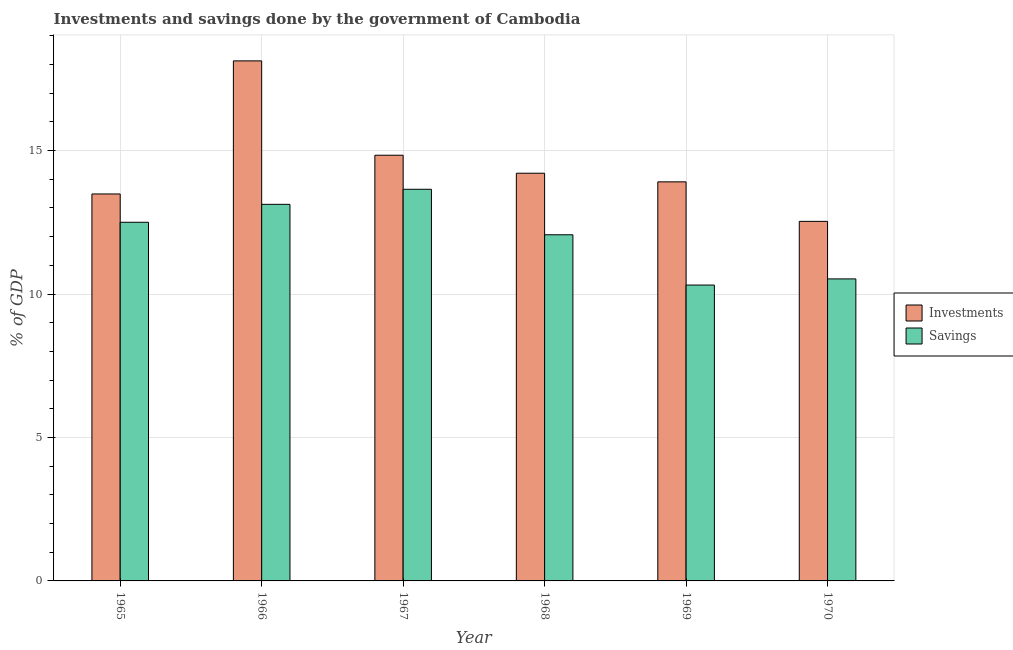How many different coloured bars are there?
Offer a terse response. 2. How many groups of bars are there?
Your response must be concise. 6. Are the number of bars per tick equal to the number of legend labels?
Keep it short and to the point. Yes. Are the number of bars on each tick of the X-axis equal?
Your response must be concise. Yes. How many bars are there on the 1st tick from the left?
Make the answer very short. 2. How many bars are there on the 2nd tick from the right?
Make the answer very short. 2. What is the label of the 6th group of bars from the left?
Make the answer very short. 1970. What is the investments of government in 1970?
Make the answer very short. 12.53. Across all years, what is the maximum savings of government?
Provide a short and direct response. 13.65. Across all years, what is the minimum savings of government?
Your answer should be very brief. 10.31. In which year was the investments of government maximum?
Ensure brevity in your answer.  1966. In which year was the investments of government minimum?
Your answer should be very brief. 1970. What is the total savings of government in the graph?
Your response must be concise. 72.18. What is the difference between the investments of government in 1967 and that in 1969?
Offer a terse response. 0.93. What is the difference between the investments of government in 1969 and the savings of government in 1970?
Provide a succinct answer. 1.38. What is the average savings of government per year?
Provide a succinct answer. 12.03. In how many years, is the investments of government greater than 7 %?
Give a very brief answer. 6. What is the ratio of the investments of government in 1965 to that in 1969?
Your answer should be compact. 0.97. Is the difference between the savings of government in 1965 and 1968 greater than the difference between the investments of government in 1965 and 1968?
Offer a very short reply. No. What is the difference between the highest and the second highest investments of government?
Provide a succinct answer. 3.29. What is the difference between the highest and the lowest investments of government?
Provide a short and direct response. 5.59. What does the 1st bar from the left in 1966 represents?
Your answer should be compact. Investments. What does the 2nd bar from the right in 1969 represents?
Give a very brief answer. Investments. How many bars are there?
Give a very brief answer. 12. Are all the bars in the graph horizontal?
Offer a very short reply. No. What is the difference between two consecutive major ticks on the Y-axis?
Offer a very short reply. 5. Are the values on the major ticks of Y-axis written in scientific E-notation?
Give a very brief answer. No. Where does the legend appear in the graph?
Provide a succinct answer. Center right. How many legend labels are there?
Provide a succinct answer. 2. How are the legend labels stacked?
Ensure brevity in your answer.  Vertical. What is the title of the graph?
Give a very brief answer. Investments and savings done by the government of Cambodia. Does "Birth rate" appear as one of the legend labels in the graph?
Offer a terse response. No. What is the label or title of the Y-axis?
Provide a short and direct response. % of GDP. What is the % of GDP of Investments in 1965?
Offer a very short reply. 13.49. What is the % of GDP of Savings in 1965?
Offer a terse response. 12.5. What is the % of GDP of Investments in 1966?
Your answer should be very brief. 18.12. What is the % of GDP in Savings in 1966?
Give a very brief answer. 13.12. What is the % of GDP in Investments in 1967?
Your response must be concise. 14.84. What is the % of GDP in Savings in 1967?
Give a very brief answer. 13.65. What is the % of GDP of Investments in 1968?
Provide a succinct answer. 14.21. What is the % of GDP in Savings in 1968?
Give a very brief answer. 12.06. What is the % of GDP of Investments in 1969?
Your answer should be compact. 13.91. What is the % of GDP in Savings in 1969?
Provide a succinct answer. 10.31. What is the % of GDP in Investments in 1970?
Make the answer very short. 12.53. What is the % of GDP in Savings in 1970?
Offer a terse response. 10.53. Across all years, what is the maximum % of GDP in Investments?
Provide a short and direct response. 18.12. Across all years, what is the maximum % of GDP in Savings?
Your answer should be very brief. 13.65. Across all years, what is the minimum % of GDP in Investments?
Offer a very short reply. 12.53. Across all years, what is the minimum % of GDP of Savings?
Your response must be concise. 10.31. What is the total % of GDP in Investments in the graph?
Your response must be concise. 87.1. What is the total % of GDP in Savings in the graph?
Offer a very short reply. 72.18. What is the difference between the % of GDP in Investments in 1965 and that in 1966?
Provide a short and direct response. -4.64. What is the difference between the % of GDP of Savings in 1965 and that in 1966?
Offer a terse response. -0.62. What is the difference between the % of GDP in Investments in 1965 and that in 1967?
Provide a short and direct response. -1.35. What is the difference between the % of GDP of Savings in 1965 and that in 1967?
Offer a terse response. -1.15. What is the difference between the % of GDP in Investments in 1965 and that in 1968?
Offer a very short reply. -0.72. What is the difference between the % of GDP of Savings in 1965 and that in 1968?
Keep it short and to the point. 0.44. What is the difference between the % of GDP in Investments in 1965 and that in 1969?
Ensure brevity in your answer.  -0.42. What is the difference between the % of GDP in Savings in 1965 and that in 1969?
Your response must be concise. 2.19. What is the difference between the % of GDP in Investments in 1965 and that in 1970?
Your answer should be compact. 0.96. What is the difference between the % of GDP of Savings in 1965 and that in 1970?
Offer a very short reply. 1.97. What is the difference between the % of GDP of Investments in 1966 and that in 1967?
Make the answer very short. 3.29. What is the difference between the % of GDP in Savings in 1966 and that in 1967?
Make the answer very short. -0.52. What is the difference between the % of GDP of Investments in 1966 and that in 1968?
Your answer should be very brief. 3.92. What is the difference between the % of GDP of Savings in 1966 and that in 1968?
Your answer should be very brief. 1.06. What is the difference between the % of GDP of Investments in 1966 and that in 1969?
Your answer should be compact. 4.22. What is the difference between the % of GDP of Savings in 1966 and that in 1969?
Your answer should be very brief. 2.81. What is the difference between the % of GDP in Investments in 1966 and that in 1970?
Your answer should be very brief. 5.59. What is the difference between the % of GDP in Savings in 1966 and that in 1970?
Provide a succinct answer. 2.6. What is the difference between the % of GDP in Investments in 1967 and that in 1968?
Offer a very short reply. 0.63. What is the difference between the % of GDP in Savings in 1967 and that in 1968?
Your answer should be very brief. 1.59. What is the difference between the % of GDP of Investments in 1967 and that in 1969?
Ensure brevity in your answer.  0.93. What is the difference between the % of GDP of Savings in 1967 and that in 1969?
Ensure brevity in your answer.  3.34. What is the difference between the % of GDP in Investments in 1967 and that in 1970?
Keep it short and to the point. 2.31. What is the difference between the % of GDP in Savings in 1967 and that in 1970?
Give a very brief answer. 3.12. What is the difference between the % of GDP in Investments in 1968 and that in 1969?
Offer a terse response. 0.3. What is the difference between the % of GDP in Savings in 1968 and that in 1969?
Give a very brief answer. 1.75. What is the difference between the % of GDP of Investments in 1968 and that in 1970?
Your answer should be very brief. 1.68. What is the difference between the % of GDP in Savings in 1968 and that in 1970?
Offer a terse response. 1.54. What is the difference between the % of GDP in Investments in 1969 and that in 1970?
Provide a short and direct response. 1.38. What is the difference between the % of GDP of Savings in 1969 and that in 1970?
Your answer should be compact. -0.21. What is the difference between the % of GDP of Investments in 1965 and the % of GDP of Savings in 1966?
Offer a very short reply. 0.36. What is the difference between the % of GDP of Investments in 1965 and the % of GDP of Savings in 1967?
Make the answer very short. -0.16. What is the difference between the % of GDP of Investments in 1965 and the % of GDP of Savings in 1968?
Your answer should be compact. 1.42. What is the difference between the % of GDP in Investments in 1965 and the % of GDP in Savings in 1969?
Ensure brevity in your answer.  3.18. What is the difference between the % of GDP of Investments in 1965 and the % of GDP of Savings in 1970?
Ensure brevity in your answer.  2.96. What is the difference between the % of GDP in Investments in 1966 and the % of GDP in Savings in 1967?
Provide a succinct answer. 4.48. What is the difference between the % of GDP in Investments in 1966 and the % of GDP in Savings in 1968?
Provide a succinct answer. 6.06. What is the difference between the % of GDP in Investments in 1966 and the % of GDP in Savings in 1969?
Your answer should be very brief. 7.81. What is the difference between the % of GDP in Investments in 1966 and the % of GDP in Savings in 1970?
Your answer should be compact. 7.6. What is the difference between the % of GDP of Investments in 1967 and the % of GDP of Savings in 1968?
Give a very brief answer. 2.77. What is the difference between the % of GDP in Investments in 1967 and the % of GDP in Savings in 1969?
Your answer should be compact. 4.53. What is the difference between the % of GDP of Investments in 1967 and the % of GDP of Savings in 1970?
Your response must be concise. 4.31. What is the difference between the % of GDP in Investments in 1968 and the % of GDP in Savings in 1969?
Your answer should be compact. 3.9. What is the difference between the % of GDP of Investments in 1968 and the % of GDP of Savings in 1970?
Give a very brief answer. 3.68. What is the difference between the % of GDP of Investments in 1969 and the % of GDP of Savings in 1970?
Your answer should be compact. 3.38. What is the average % of GDP of Investments per year?
Provide a succinct answer. 14.52. What is the average % of GDP in Savings per year?
Ensure brevity in your answer.  12.03. In the year 1966, what is the difference between the % of GDP in Investments and % of GDP in Savings?
Your answer should be compact. 5. In the year 1967, what is the difference between the % of GDP in Investments and % of GDP in Savings?
Provide a succinct answer. 1.19. In the year 1968, what is the difference between the % of GDP of Investments and % of GDP of Savings?
Offer a terse response. 2.14. In the year 1969, what is the difference between the % of GDP of Investments and % of GDP of Savings?
Keep it short and to the point. 3.6. In the year 1970, what is the difference between the % of GDP of Investments and % of GDP of Savings?
Offer a terse response. 2. What is the ratio of the % of GDP of Investments in 1965 to that in 1966?
Make the answer very short. 0.74. What is the ratio of the % of GDP in Savings in 1965 to that in 1966?
Make the answer very short. 0.95. What is the ratio of the % of GDP in Investments in 1965 to that in 1967?
Your answer should be very brief. 0.91. What is the ratio of the % of GDP in Savings in 1965 to that in 1967?
Make the answer very short. 0.92. What is the ratio of the % of GDP of Investments in 1965 to that in 1968?
Ensure brevity in your answer.  0.95. What is the ratio of the % of GDP in Savings in 1965 to that in 1968?
Your answer should be very brief. 1.04. What is the ratio of the % of GDP of Investments in 1965 to that in 1969?
Make the answer very short. 0.97. What is the ratio of the % of GDP in Savings in 1965 to that in 1969?
Make the answer very short. 1.21. What is the ratio of the % of GDP of Investments in 1965 to that in 1970?
Ensure brevity in your answer.  1.08. What is the ratio of the % of GDP in Savings in 1965 to that in 1970?
Provide a succinct answer. 1.19. What is the ratio of the % of GDP in Investments in 1966 to that in 1967?
Your answer should be compact. 1.22. What is the ratio of the % of GDP in Savings in 1966 to that in 1967?
Give a very brief answer. 0.96. What is the ratio of the % of GDP in Investments in 1966 to that in 1968?
Offer a very short reply. 1.28. What is the ratio of the % of GDP of Savings in 1966 to that in 1968?
Keep it short and to the point. 1.09. What is the ratio of the % of GDP of Investments in 1966 to that in 1969?
Make the answer very short. 1.3. What is the ratio of the % of GDP in Savings in 1966 to that in 1969?
Your answer should be compact. 1.27. What is the ratio of the % of GDP in Investments in 1966 to that in 1970?
Provide a succinct answer. 1.45. What is the ratio of the % of GDP of Savings in 1966 to that in 1970?
Offer a terse response. 1.25. What is the ratio of the % of GDP in Investments in 1967 to that in 1968?
Provide a short and direct response. 1.04. What is the ratio of the % of GDP of Savings in 1967 to that in 1968?
Keep it short and to the point. 1.13. What is the ratio of the % of GDP in Investments in 1967 to that in 1969?
Offer a terse response. 1.07. What is the ratio of the % of GDP of Savings in 1967 to that in 1969?
Offer a very short reply. 1.32. What is the ratio of the % of GDP of Investments in 1967 to that in 1970?
Ensure brevity in your answer.  1.18. What is the ratio of the % of GDP of Savings in 1967 to that in 1970?
Your answer should be compact. 1.3. What is the ratio of the % of GDP in Investments in 1968 to that in 1969?
Your response must be concise. 1.02. What is the ratio of the % of GDP of Savings in 1968 to that in 1969?
Make the answer very short. 1.17. What is the ratio of the % of GDP in Investments in 1968 to that in 1970?
Make the answer very short. 1.13. What is the ratio of the % of GDP in Savings in 1968 to that in 1970?
Offer a very short reply. 1.15. What is the ratio of the % of GDP of Investments in 1969 to that in 1970?
Provide a short and direct response. 1.11. What is the ratio of the % of GDP of Savings in 1969 to that in 1970?
Your answer should be compact. 0.98. What is the difference between the highest and the second highest % of GDP in Investments?
Ensure brevity in your answer.  3.29. What is the difference between the highest and the second highest % of GDP in Savings?
Offer a very short reply. 0.52. What is the difference between the highest and the lowest % of GDP in Investments?
Offer a very short reply. 5.59. What is the difference between the highest and the lowest % of GDP in Savings?
Your answer should be compact. 3.34. 